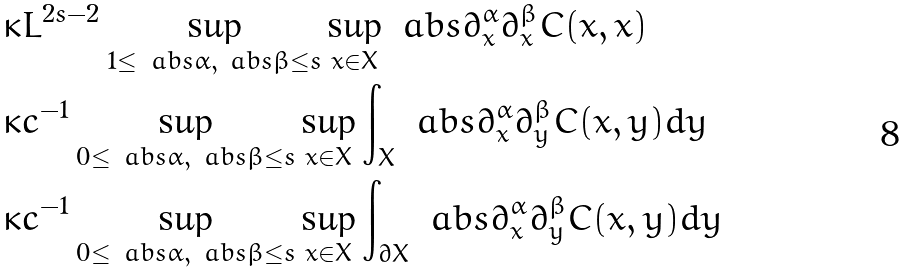Convert formula to latex. <formula><loc_0><loc_0><loc_500><loc_500>& \kappa L ^ { 2 s - 2 } \sup _ { 1 \leq \ a b s { \alpha } , \ a b s { \beta } \leq s } \sup _ { x \in X } \ a b s { \partial _ { x } ^ { \alpha } \partial _ { x } ^ { \beta } C ( x , x ) } \\ & \kappa c ^ { - 1 } \sup _ { 0 \leq \ a b s { \alpha } , \ a b s { \beta } \leq s } \sup _ { x \in X } \int _ { X } \ a b s { \partial _ { x } ^ { \alpha } \partial _ { y } ^ { \beta } C ( x , y ) } d y \\ & \kappa c ^ { - 1 } \sup _ { 0 \leq \ a b s { \alpha } , \ a b s { \beta } \leq s } \sup _ { x \in X } \int _ { \partial X } \ a b s { \partial _ { x } ^ { \alpha } \partial _ { y } ^ { \beta } C ( x , y ) } d y</formula> 